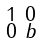<formula> <loc_0><loc_0><loc_500><loc_500>\begin{smallmatrix} 1 & 0 \\ 0 & b \end{smallmatrix}</formula> 